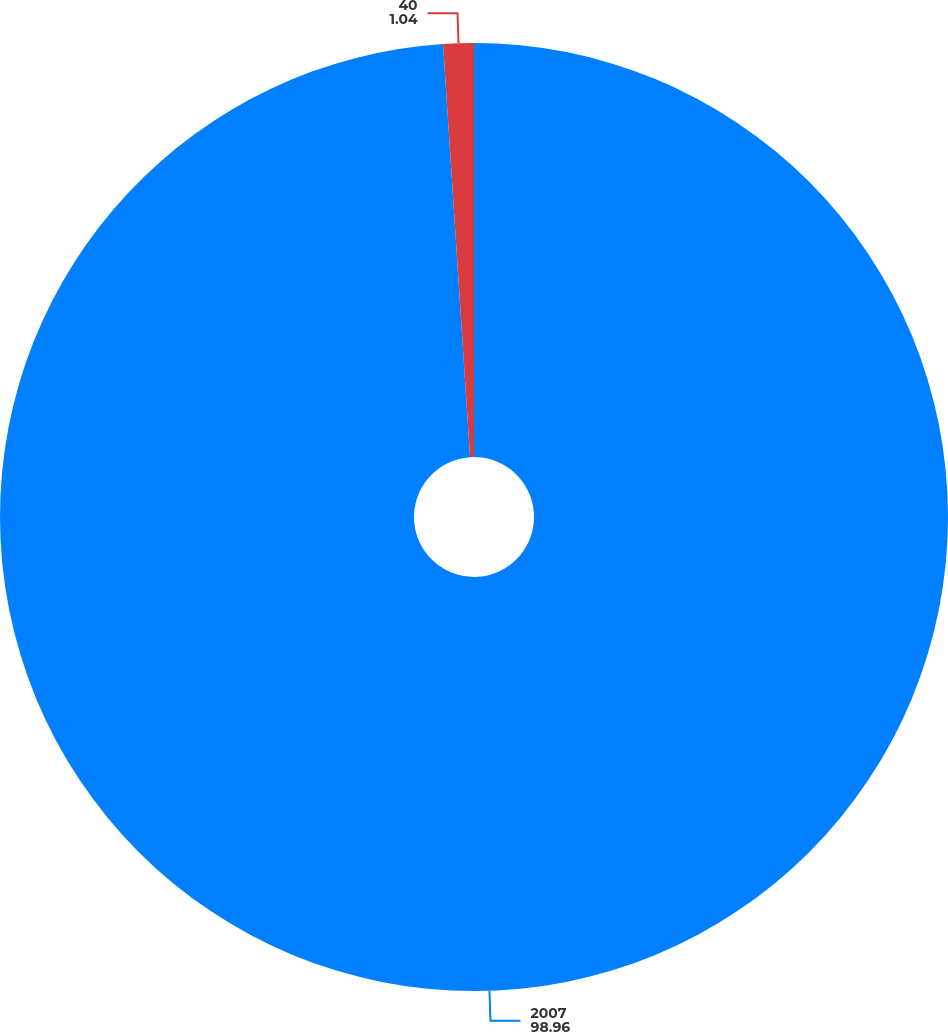<chart> <loc_0><loc_0><loc_500><loc_500><pie_chart><fcel>2007<fcel>40<nl><fcel>98.96%<fcel>1.04%<nl></chart> 